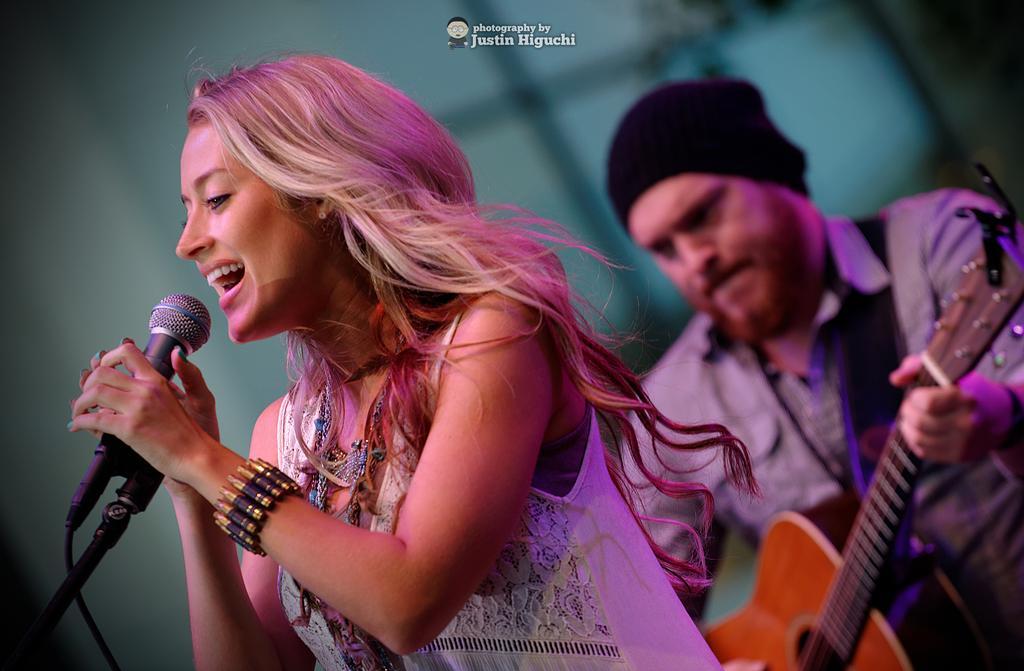How would you summarize this image in a sentence or two? in this picture we can see a man playing a guitar wearing a black cap. Here we can see one woman standing and singing by holding a mike in her hands. 